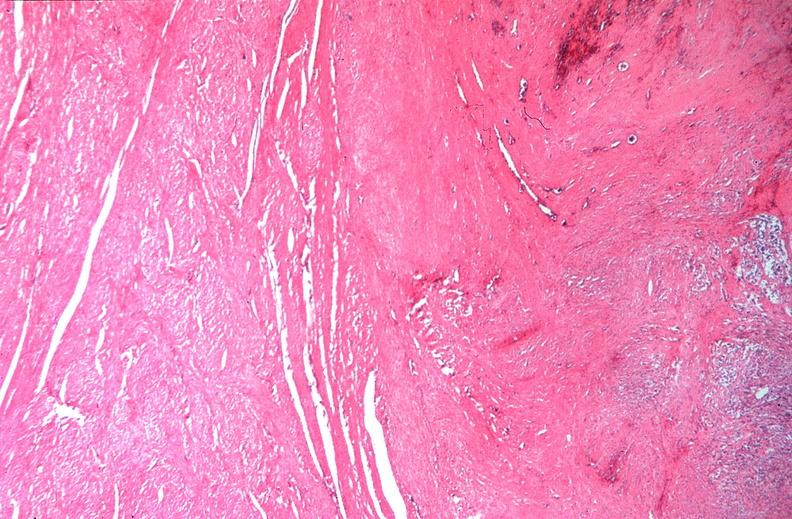does chest and abdomen slide show uterus, leiomyomas?
Answer the question using a single word or phrase. No 